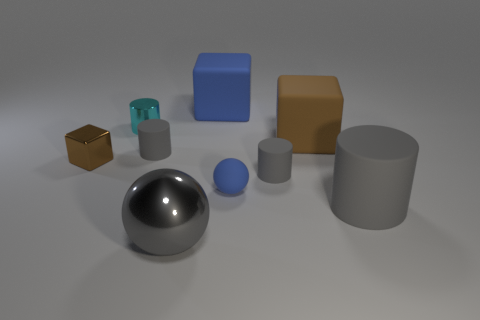Can you estimate the size of these objects in relation to each other? While exact sizes are difficult to determine without a reference, the objects have a clear relative scale. The sphere and cylinders appear to be the largest objects in terms of volume, followed by the larger blocks, while the small cube and ball are the smallest. If this were a still life painting, what mood or theme would it convey? If interpreted as a still life painting, this assembly of objects might convey a theme of simplicity and order, with an undercurrent of contemplation. The neutral background and the careful placement of objects give it a serene, almost meditative quality, with the play on geometry and light adding to its artistic appeal. 